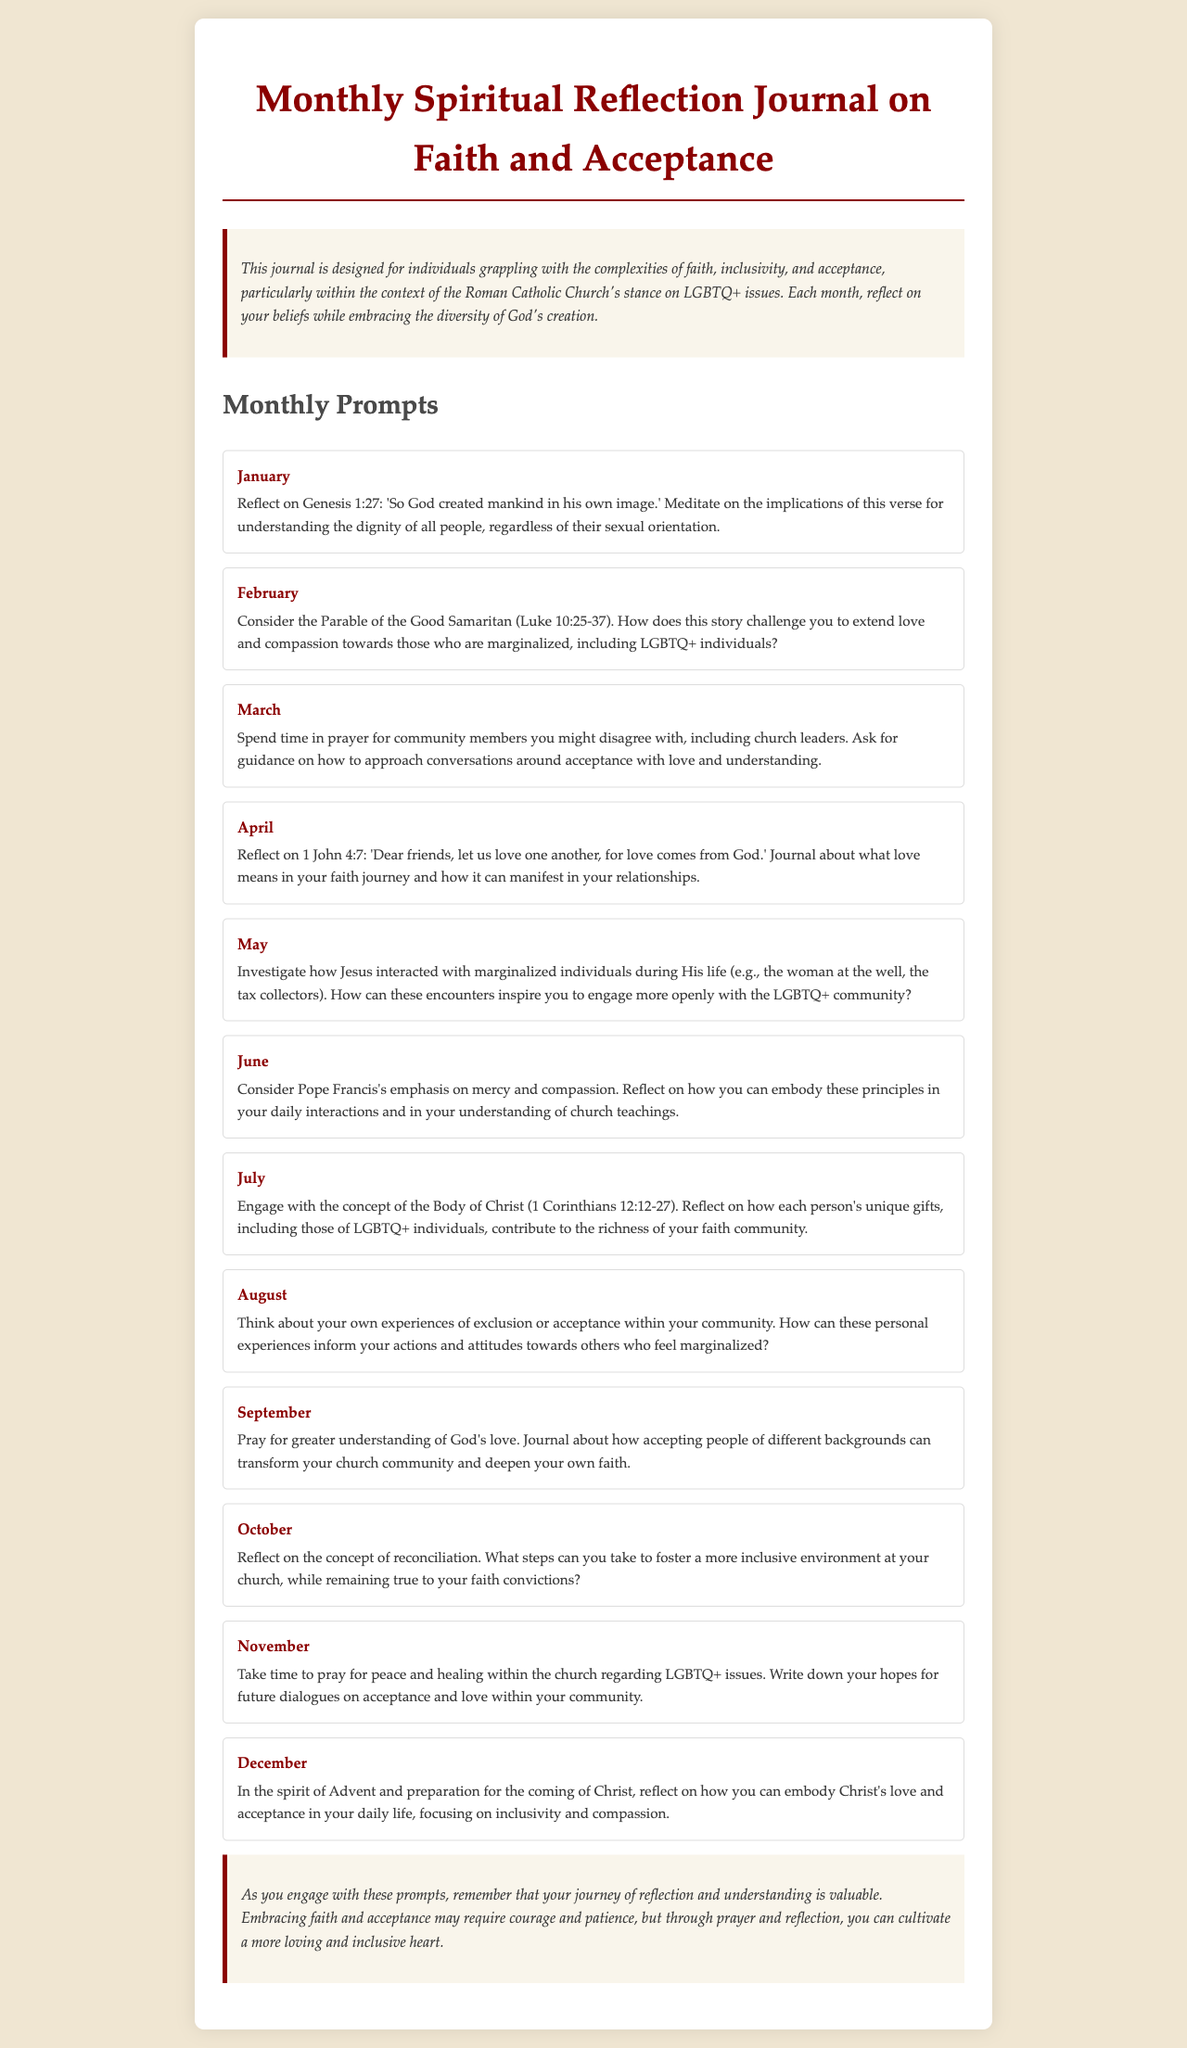What is the title of the journal? The title of the journal is stated at the top of the document, which provides the main focus for readers.
Answer: Monthly Spiritual Reflection Journal on Faith and Acceptance What is the main purpose of the journal? The main purpose is explained in the introductory paragraph, detailing the journal's aim to assist individuals in their spiritual journey.
Answer: To reflect on the complexities of faith, inclusivity, and acceptance Which month features the prompt about Genesis 1:27? The month associated with this particular scriptural reflection is mentioned in the prompts section, specifying when to meditate on this verse.
Answer: January How many monthly prompts are provided in the journal? The total number of monthly prompts can be counted from the section listing each month's reflection prompt.
Answer: Twelve What Bible verse is referenced in June's prompt? The relevant verse for that month can be found within the text of the prompt section, highlighting its importance for reflection.
Answer: None What is the theme of the prompt for February? The theme of February's prompt is highlighted by focusing on a specific parable that encourages compassion.
Answer: The Parable of the Good Samaritan In which month should you pray for peace and healing regarding LGBTQ+ issues? The specific month for this prayer is outlined in the corresponding prompt about hopes for dialogue within the church.
Answer: November What action does the conclusion suggest regarding personal reflection? The closing section emphasizes the importance of a specific action related to the reader's journey in understanding faith and acceptance.
Answer: Cultivate a more loving and inclusive heart 